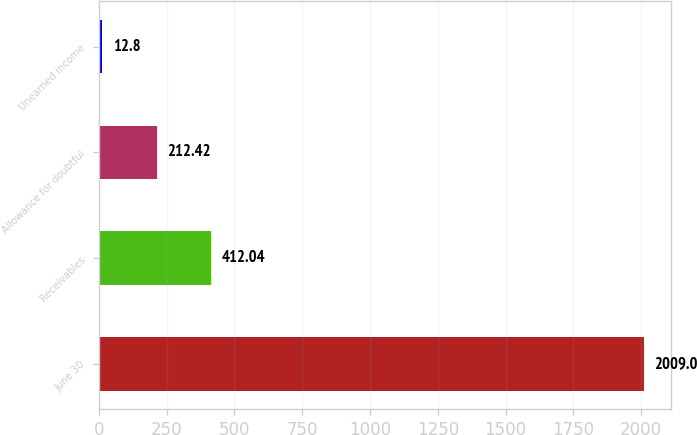Convert chart to OTSL. <chart><loc_0><loc_0><loc_500><loc_500><bar_chart><fcel>June 30<fcel>Receivables<fcel>Allowance for doubtful<fcel>Unearned income<nl><fcel>2009<fcel>412.04<fcel>212.42<fcel>12.8<nl></chart> 